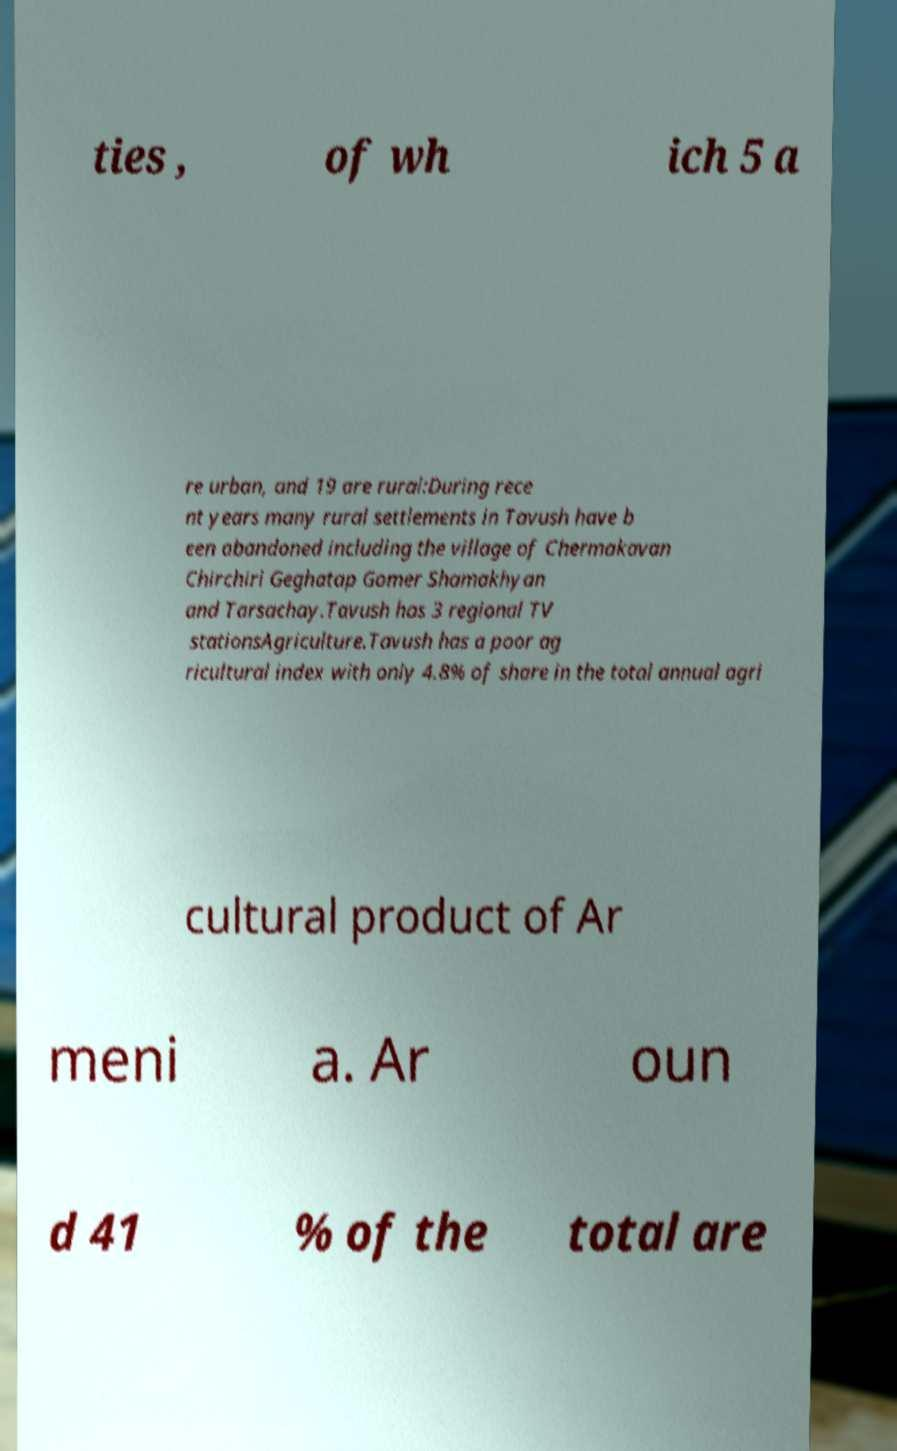Could you extract and type out the text from this image? ties , of wh ich 5 a re urban, and 19 are rural:During rece nt years many rural settlements in Tavush have b een abandoned including the village of Chermakavan Chirchiri Geghatap Gomer Shamakhyan and Tarsachay.Tavush has 3 regional TV stationsAgriculture.Tavush has a poor ag ricultural index with only 4.8% of share in the total annual agri cultural product of Ar meni a. Ar oun d 41 % of the total are 